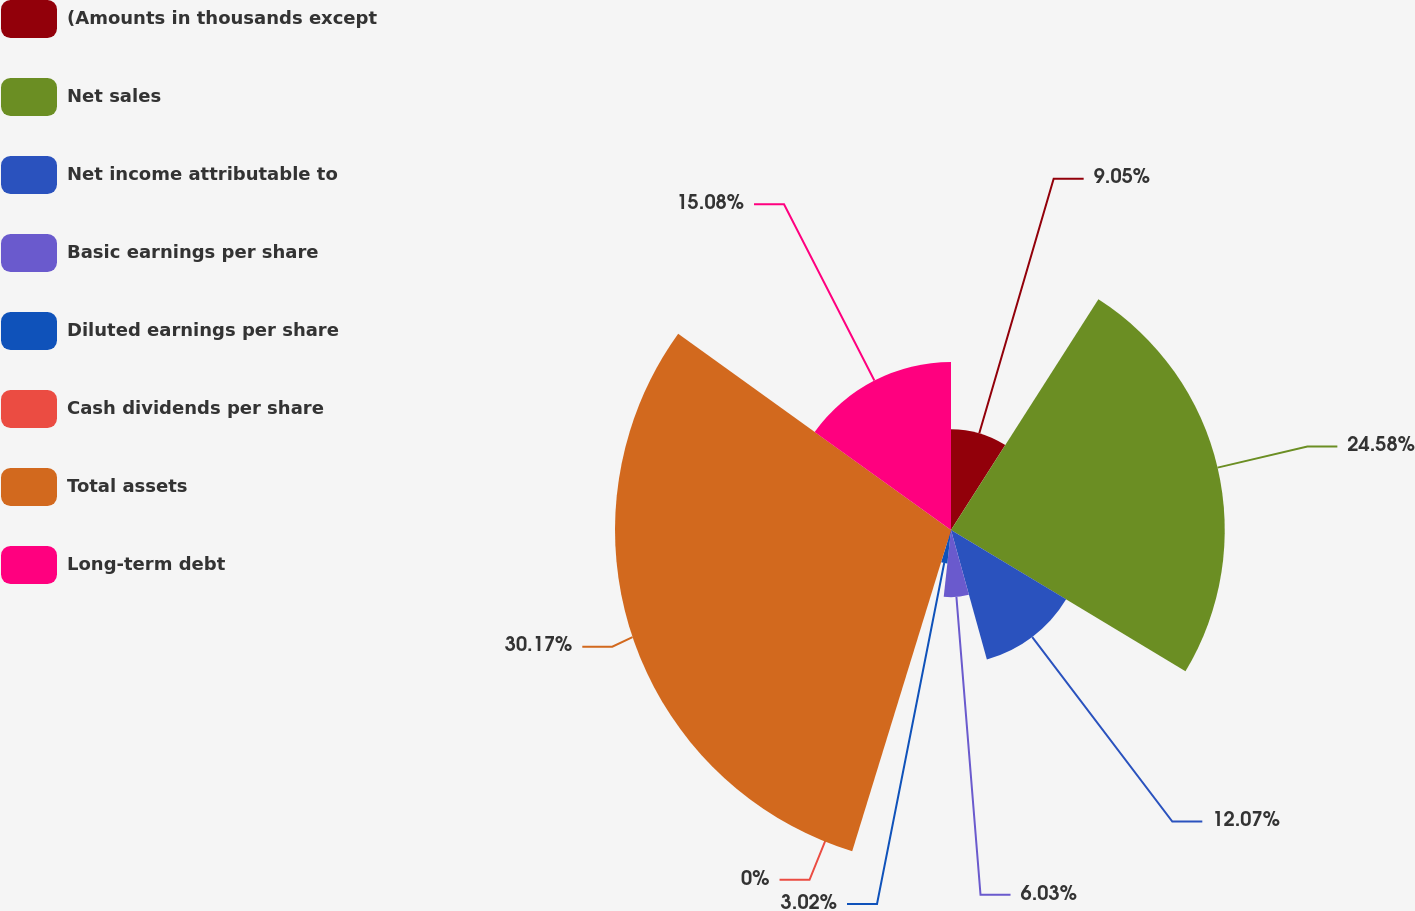Convert chart. <chart><loc_0><loc_0><loc_500><loc_500><pie_chart><fcel>(Amounts in thousands except<fcel>Net sales<fcel>Net income attributable to<fcel>Basic earnings per share<fcel>Diluted earnings per share<fcel>Cash dividends per share<fcel>Total assets<fcel>Long-term debt<nl><fcel>9.05%<fcel>24.58%<fcel>12.07%<fcel>6.03%<fcel>3.02%<fcel>0.0%<fcel>30.17%<fcel>15.08%<nl></chart> 